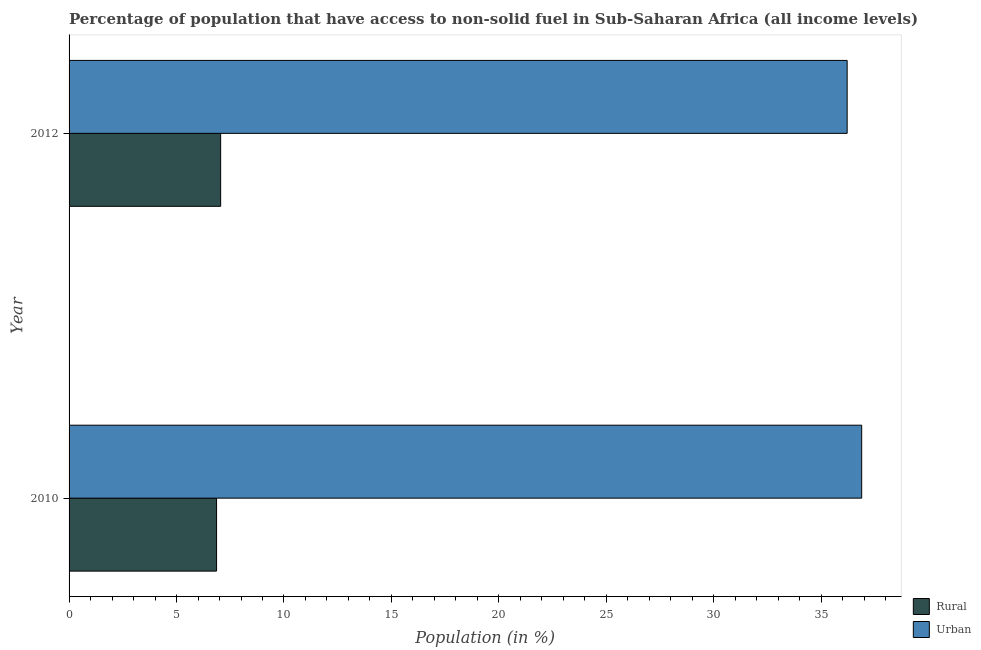How many different coloured bars are there?
Offer a terse response. 2. Are the number of bars on each tick of the Y-axis equal?
Provide a short and direct response. Yes. How many bars are there on the 1st tick from the top?
Ensure brevity in your answer.  2. How many bars are there on the 1st tick from the bottom?
Make the answer very short. 2. What is the label of the 2nd group of bars from the top?
Offer a terse response. 2010. What is the urban population in 2010?
Give a very brief answer. 36.88. Across all years, what is the maximum urban population?
Ensure brevity in your answer.  36.88. Across all years, what is the minimum urban population?
Give a very brief answer. 36.2. In which year was the rural population minimum?
Give a very brief answer. 2010. What is the total rural population in the graph?
Your response must be concise. 13.92. What is the difference between the urban population in 2010 and that in 2012?
Offer a very short reply. 0.68. What is the difference between the urban population in 2010 and the rural population in 2012?
Provide a short and direct response. 29.83. What is the average rural population per year?
Your answer should be very brief. 6.96. In the year 2012, what is the difference between the rural population and urban population?
Make the answer very short. -29.15. Is the rural population in 2010 less than that in 2012?
Keep it short and to the point. Yes. In how many years, is the urban population greater than the average urban population taken over all years?
Provide a succinct answer. 1. What does the 1st bar from the top in 2012 represents?
Ensure brevity in your answer.  Urban. What does the 2nd bar from the bottom in 2012 represents?
Give a very brief answer. Urban. How many bars are there?
Provide a short and direct response. 4. How many years are there in the graph?
Make the answer very short. 2. Are the values on the major ticks of X-axis written in scientific E-notation?
Provide a short and direct response. No. Does the graph contain any zero values?
Provide a succinct answer. No. Does the graph contain grids?
Your answer should be very brief. No. How many legend labels are there?
Keep it short and to the point. 2. How are the legend labels stacked?
Offer a terse response. Vertical. What is the title of the graph?
Offer a terse response. Percentage of population that have access to non-solid fuel in Sub-Saharan Africa (all income levels). What is the label or title of the X-axis?
Ensure brevity in your answer.  Population (in %). What is the Population (in %) of Rural in 2010?
Give a very brief answer. 6.86. What is the Population (in %) in Urban in 2010?
Your answer should be very brief. 36.88. What is the Population (in %) of Rural in 2012?
Your answer should be compact. 7.05. What is the Population (in %) of Urban in 2012?
Provide a short and direct response. 36.2. Across all years, what is the maximum Population (in %) in Rural?
Give a very brief answer. 7.05. Across all years, what is the maximum Population (in %) of Urban?
Your answer should be very brief. 36.88. Across all years, what is the minimum Population (in %) of Rural?
Ensure brevity in your answer.  6.86. Across all years, what is the minimum Population (in %) of Urban?
Provide a short and direct response. 36.2. What is the total Population (in %) of Rural in the graph?
Your answer should be very brief. 13.92. What is the total Population (in %) of Urban in the graph?
Provide a succinct answer. 73.08. What is the difference between the Population (in %) in Rural in 2010 and that in 2012?
Your answer should be compact. -0.19. What is the difference between the Population (in %) of Urban in 2010 and that in 2012?
Offer a terse response. 0.68. What is the difference between the Population (in %) of Rural in 2010 and the Population (in %) of Urban in 2012?
Give a very brief answer. -29.34. What is the average Population (in %) of Rural per year?
Ensure brevity in your answer.  6.96. What is the average Population (in %) of Urban per year?
Ensure brevity in your answer.  36.54. In the year 2010, what is the difference between the Population (in %) in Rural and Population (in %) in Urban?
Keep it short and to the point. -30.02. In the year 2012, what is the difference between the Population (in %) of Rural and Population (in %) of Urban?
Make the answer very short. -29.15. What is the ratio of the Population (in %) in Rural in 2010 to that in 2012?
Offer a very short reply. 0.97. What is the ratio of the Population (in %) of Urban in 2010 to that in 2012?
Offer a terse response. 1.02. What is the difference between the highest and the second highest Population (in %) in Rural?
Your response must be concise. 0.19. What is the difference between the highest and the second highest Population (in %) of Urban?
Your answer should be very brief. 0.68. What is the difference between the highest and the lowest Population (in %) of Rural?
Offer a very short reply. 0.19. What is the difference between the highest and the lowest Population (in %) in Urban?
Offer a terse response. 0.68. 